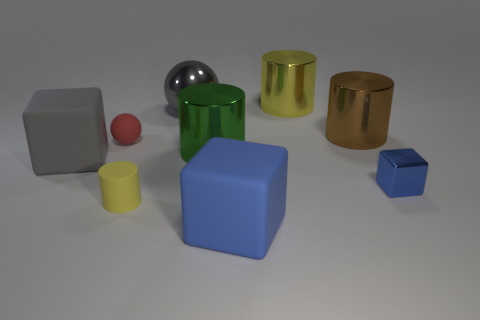Are there fewer big green metallic cylinders in front of the gray matte cube than large cyan rubber things?
Offer a very short reply. No. The big block in front of the large matte cube left of the rubber cube right of the big gray rubber thing is made of what material?
Your response must be concise. Rubber. What number of things are either big shiny cylinders right of the green metallic object or big cylinders that are in front of the small sphere?
Keep it short and to the point. 3. What material is the other object that is the same shape as the large gray metal object?
Provide a short and direct response. Rubber. How many rubber objects are either tiny red objects or gray spheres?
Make the answer very short. 1. The big gray thing that is made of the same material as the small blue object is what shape?
Ensure brevity in your answer.  Sphere. What number of other small things have the same shape as the yellow metallic object?
Your answer should be very brief. 1. Do the large object that is behind the metal ball and the tiny object left of the tiny yellow rubber cylinder have the same shape?
Offer a very short reply. No. How many objects are large gray metallic spheres or cylinders that are on the left side of the big yellow metallic thing?
Make the answer very short. 3. What shape is the matte thing that is the same color as the small shiny cube?
Your response must be concise. Cube. 